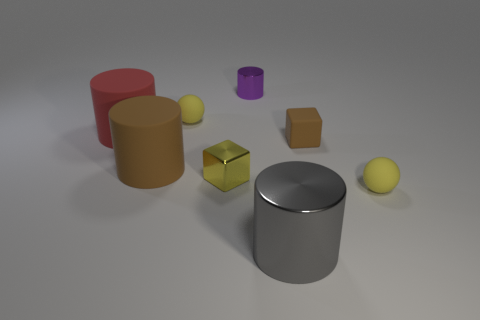Subtract all tiny purple metal cylinders. How many cylinders are left? 3 Add 1 big gray spheres. How many objects exist? 9 Subtract all yellow cubes. How many cubes are left? 1 Subtract 1 cylinders. How many cylinders are left? 3 Subtract all red balls. Subtract all blue cylinders. How many balls are left? 2 Subtract all green balls. How many red cylinders are left? 1 Subtract all yellow things. Subtract all tiny yellow rubber objects. How many objects are left? 3 Add 3 purple metallic objects. How many purple metallic objects are left? 4 Add 2 small yellow rubber things. How many small yellow rubber things exist? 4 Subtract 0 cyan spheres. How many objects are left? 8 